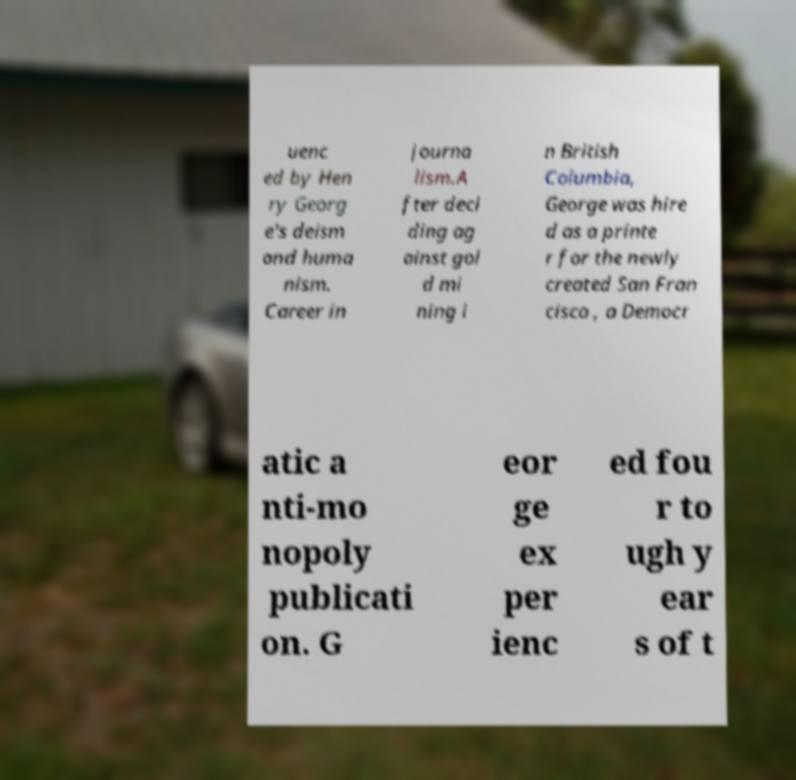Please identify and transcribe the text found in this image. uenc ed by Hen ry Georg e's deism and huma nism. Career in journa lism.A fter deci ding ag ainst gol d mi ning i n British Columbia, George was hire d as a printe r for the newly created San Fran cisco , a Democr atic a nti-mo nopoly publicati on. G eor ge ex per ienc ed fou r to ugh y ear s of t 